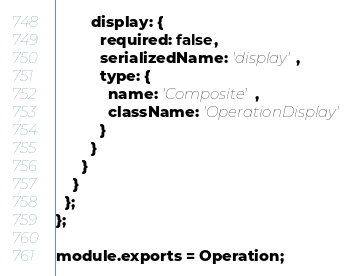<code> <loc_0><loc_0><loc_500><loc_500><_JavaScript_>        display: {
          required: false,
          serializedName: 'display',
          type: {
            name: 'Composite',
            className: 'OperationDisplay'
          }
        }
      }
    }
  };
};

module.exports = Operation;
</code> 